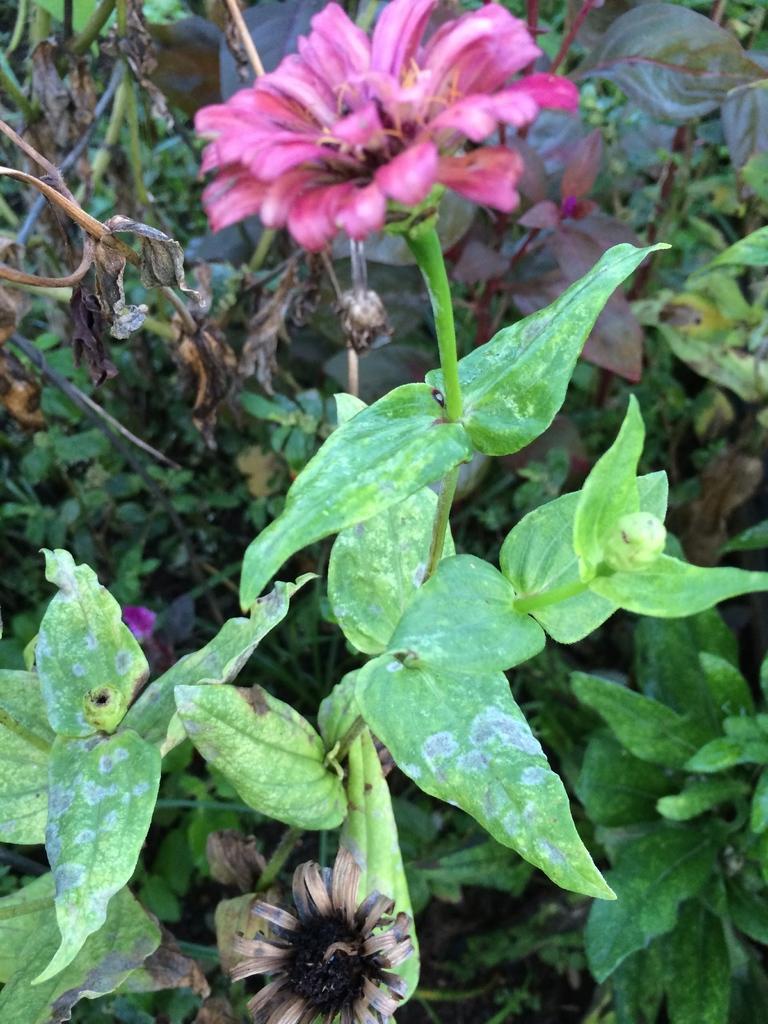How would you summarize this image in a sentence or two? In this picture there is flower plant in the center of the image and there are other plants in the background area of the image. 